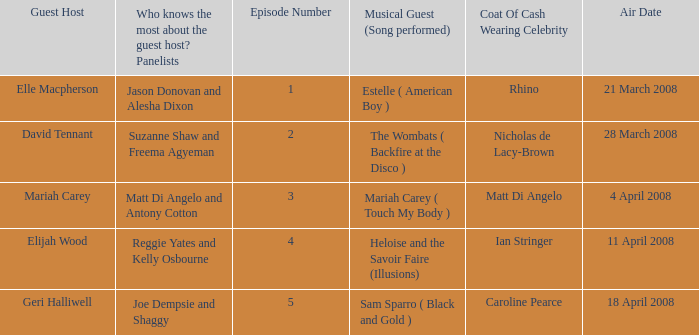Name the number of panelists for oat of cash wearing celebrity being matt di angelo 1.0. 